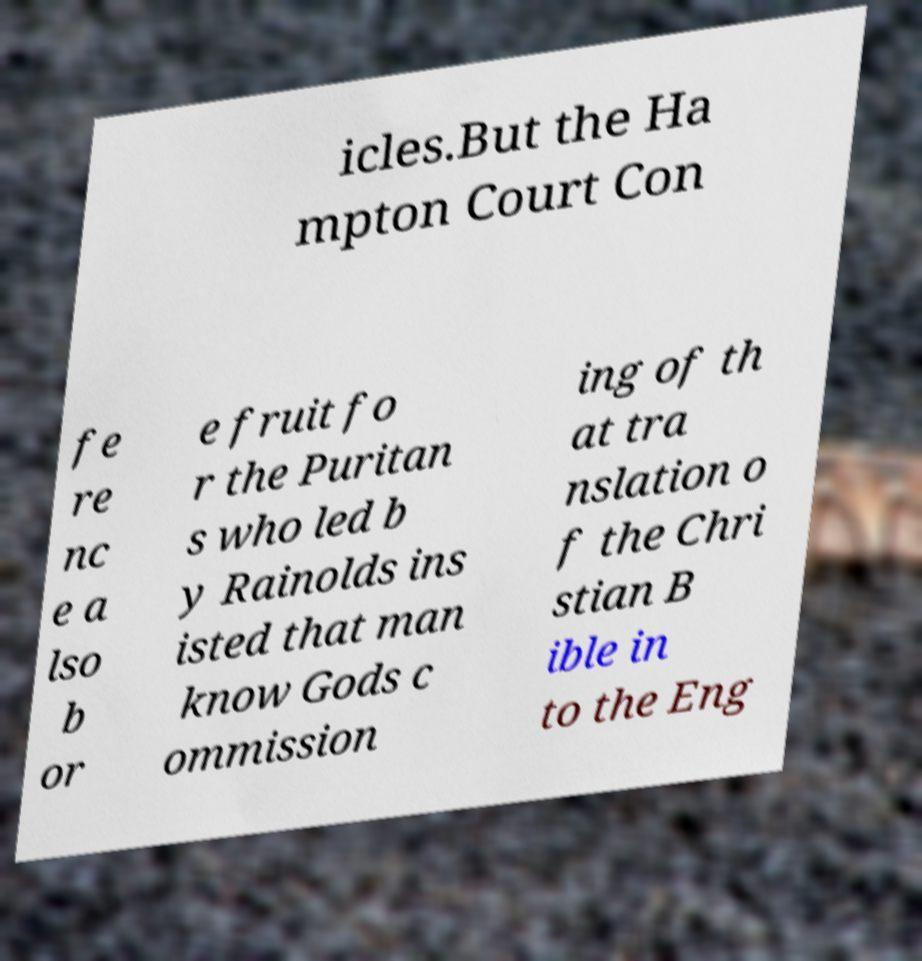Could you assist in decoding the text presented in this image and type it out clearly? icles.But the Ha mpton Court Con fe re nc e a lso b or e fruit fo r the Puritan s who led b y Rainolds ins isted that man know Gods c ommission ing of th at tra nslation o f the Chri stian B ible in to the Eng 